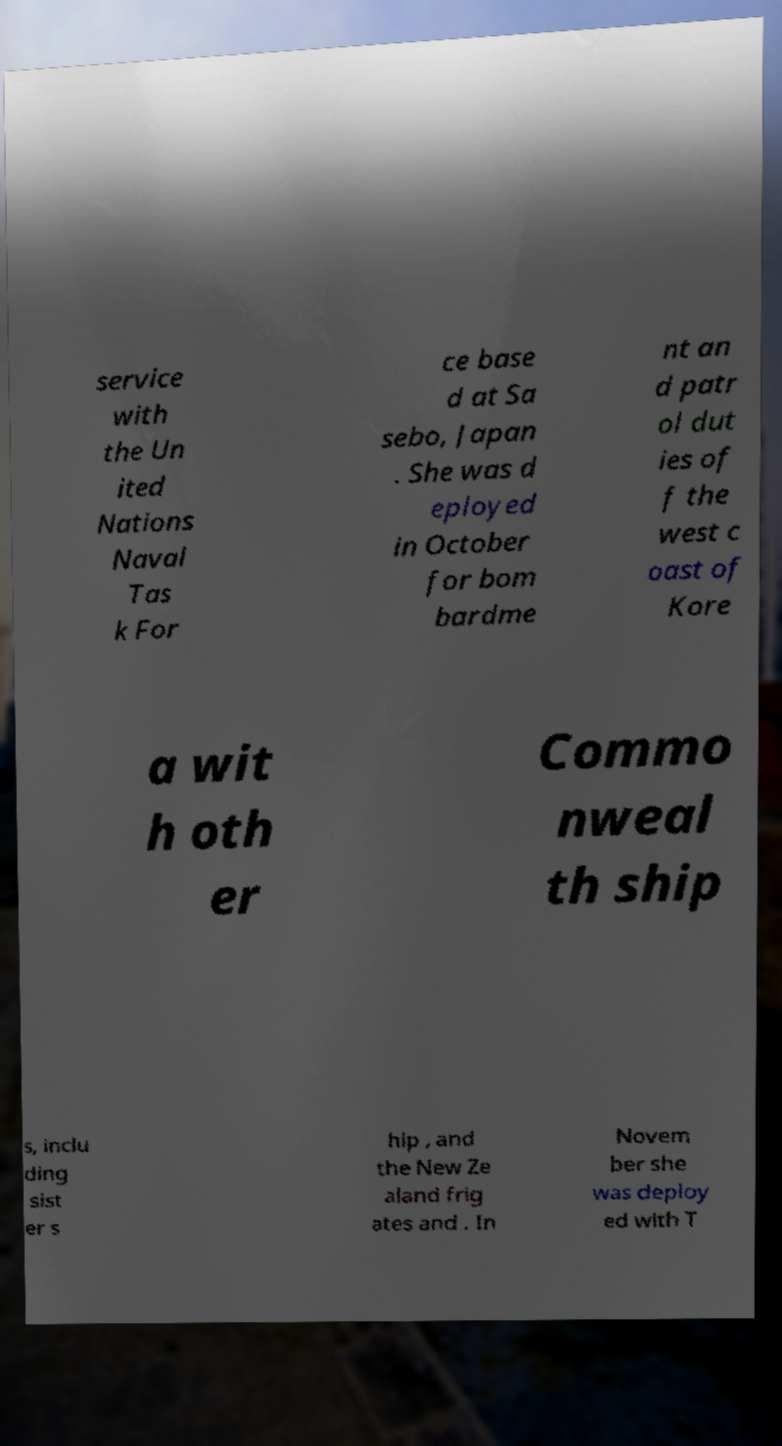I need the written content from this picture converted into text. Can you do that? service with the Un ited Nations Naval Tas k For ce base d at Sa sebo, Japan . She was d eployed in October for bom bardme nt an d patr ol dut ies of f the west c oast of Kore a wit h oth er Commo nweal th ship s, inclu ding sist er s hip , and the New Ze aland frig ates and . In Novem ber she was deploy ed with T 